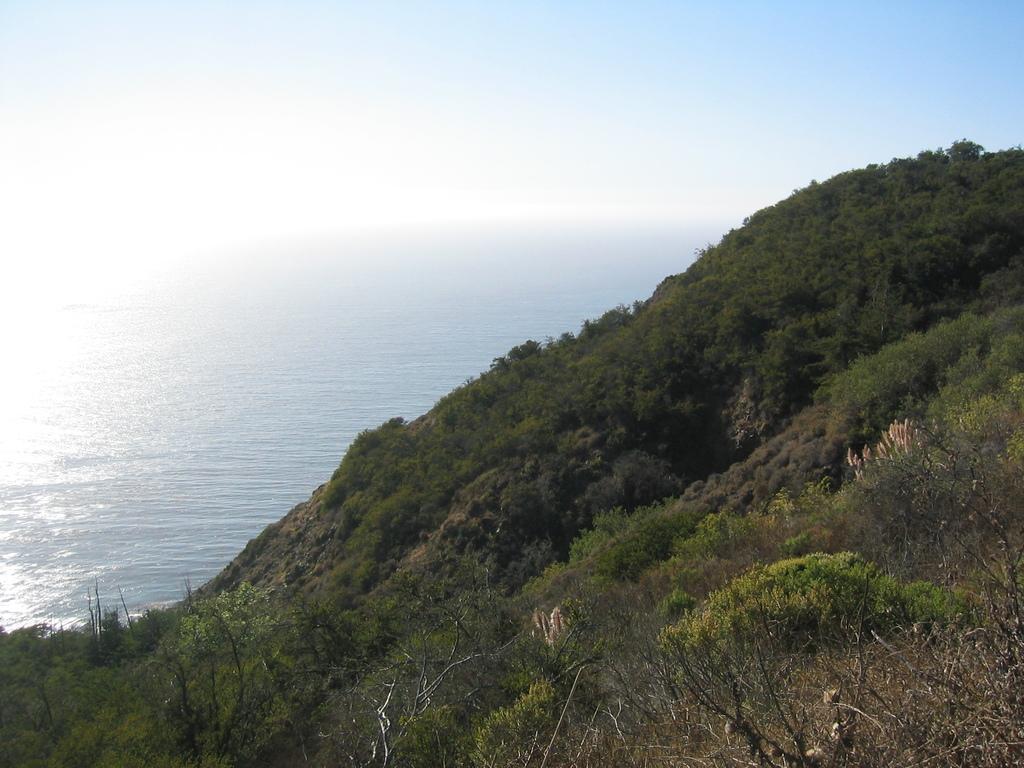In one or two sentences, can you explain what this image depicts? This picture shows trees on the hill and we see water and a blue sky. 